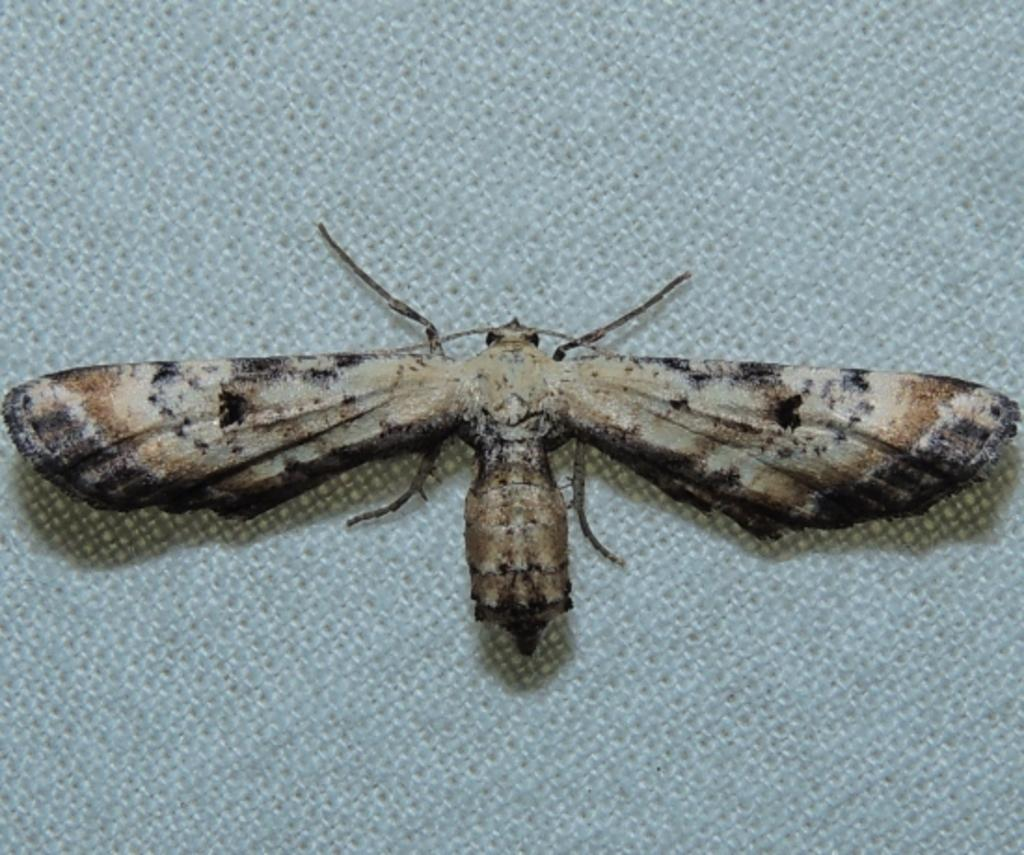What is on the floor in the picture? There is a mat in the picture. What is on top of the mat? A butterfly is present on the mat. What is the butterfly doing in the picture? The butterfly has its wings open. What is the manager doing in the picture? There is no manager present in the picture; it features a mat with a butterfly on it. How many trees are visible in the picture? There are no trees visible in the picture; it only shows a mat with a butterfly on it. 